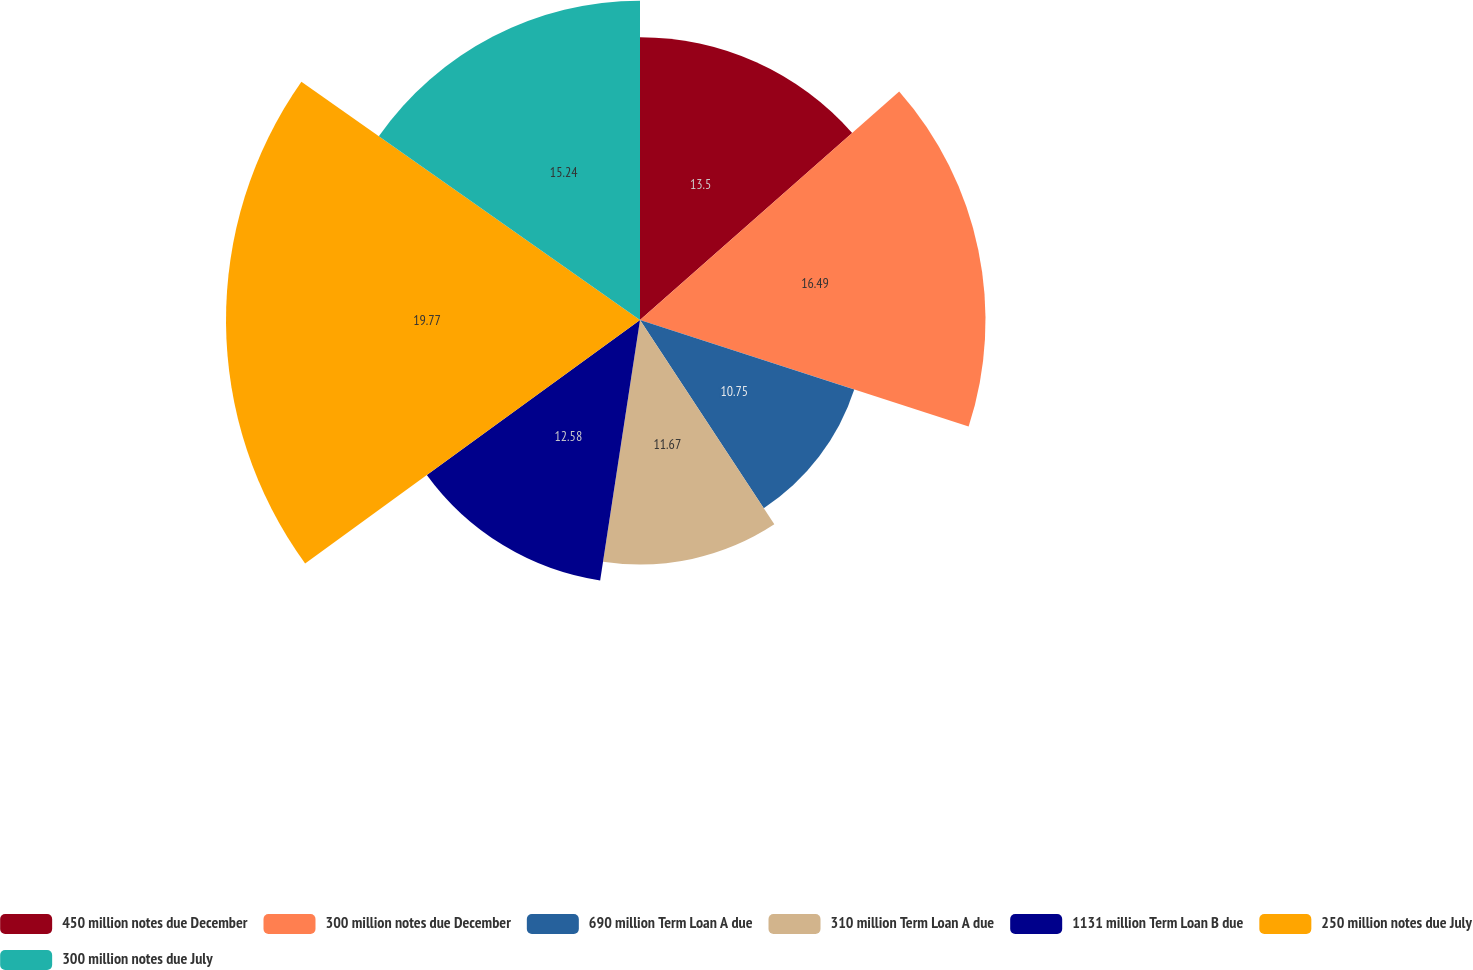<chart> <loc_0><loc_0><loc_500><loc_500><pie_chart><fcel>450 million notes due December<fcel>300 million notes due December<fcel>690 million Term Loan A due<fcel>310 million Term Loan A due<fcel>1131 million Term Loan B due<fcel>250 million notes due July<fcel>300 million notes due July<nl><fcel>13.5%<fcel>16.49%<fcel>10.75%<fcel>11.67%<fcel>12.58%<fcel>19.76%<fcel>15.24%<nl></chart> 